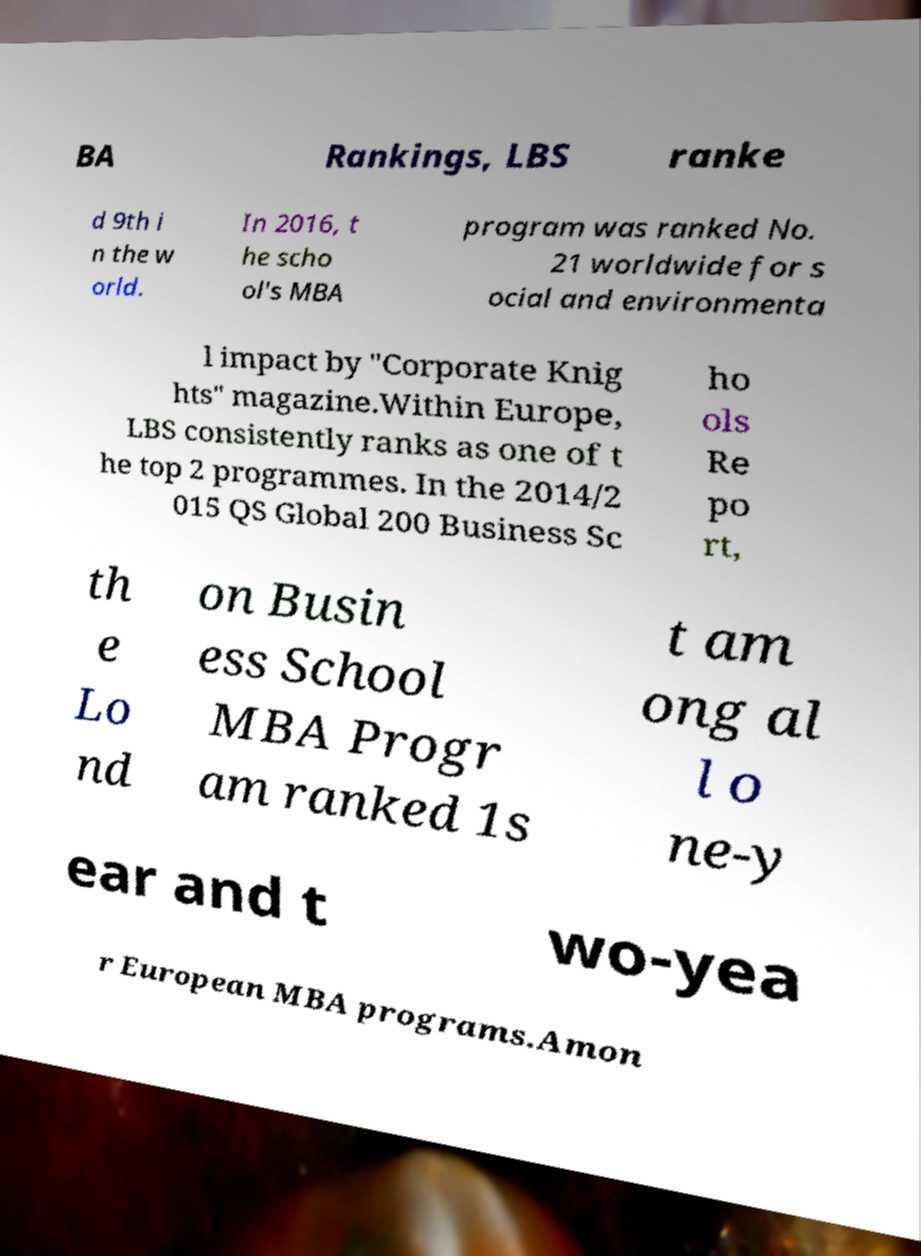Can you accurately transcribe the text from the provided image for me? BA Rankings, LBS ranke d 9th i n the w orld. In 2016, t he scho ol's MBA program was ranked No. 21 worldwide for s ocial and environmenta l impact by "Corporate Knig hts" magazine.Within Europe, LBS consistently ranks as one of t he top 2 programmes. In the 2014/2 015 QS Global 200 Business Sc ho ols Re po rt, th e Lo nd on Busin ess School MBA Progr am ranked 1s t am ong al l o ne-y ear and t wo-yea r European MBA programs.Amon 